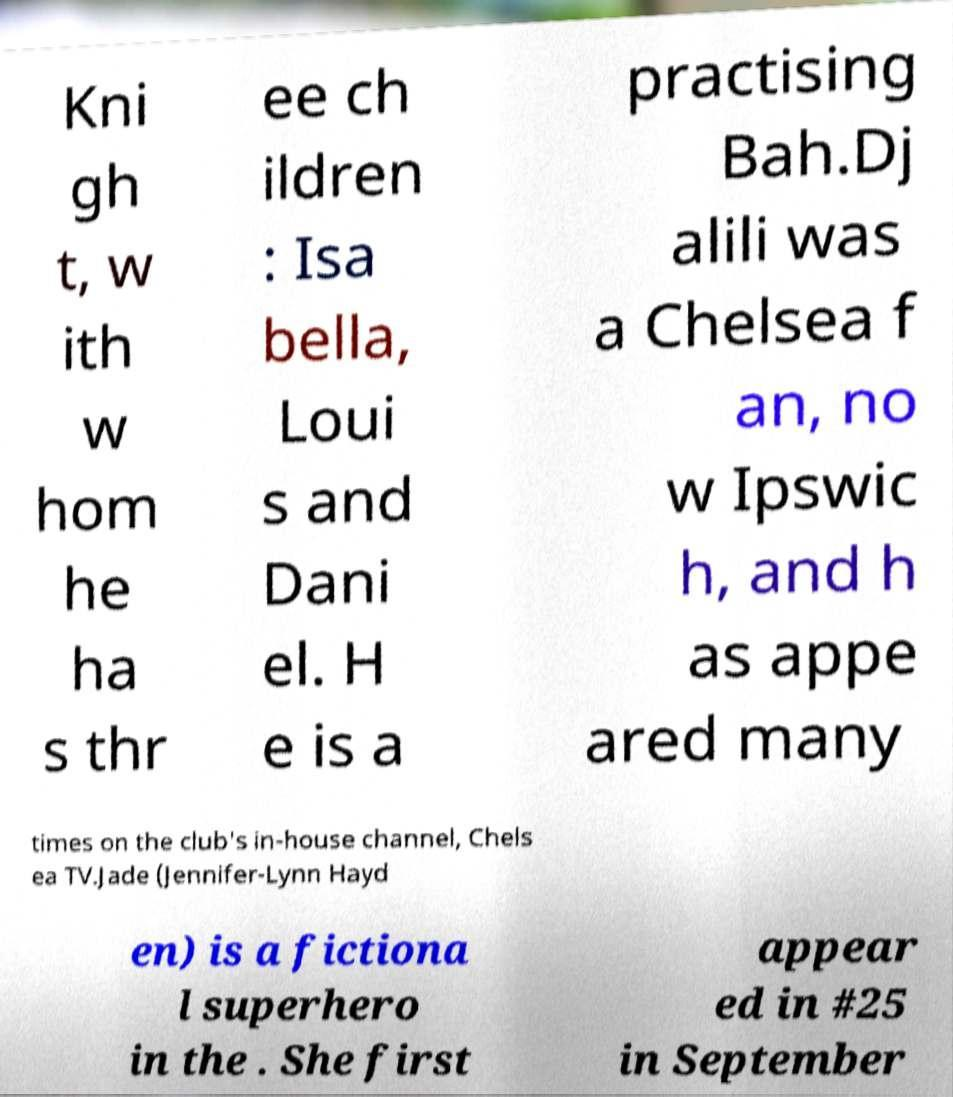There's text embedded in this image that I need extracted. Can you transcribe it verbatim? Kni gh t, w ith w hom he ha s thr ee ch ildren : Isa bella, Loui s and Dani el. H e is a practising Bah.Dj alili was a Chelsea f an, no w Ipswic h, and h as appe ared many times on the club's in-house channel, Chels ea TV.Jade (Jennifer-Lynn Hayd en) is a fictiona l superhero in the . She first appear ed in #25 in September 